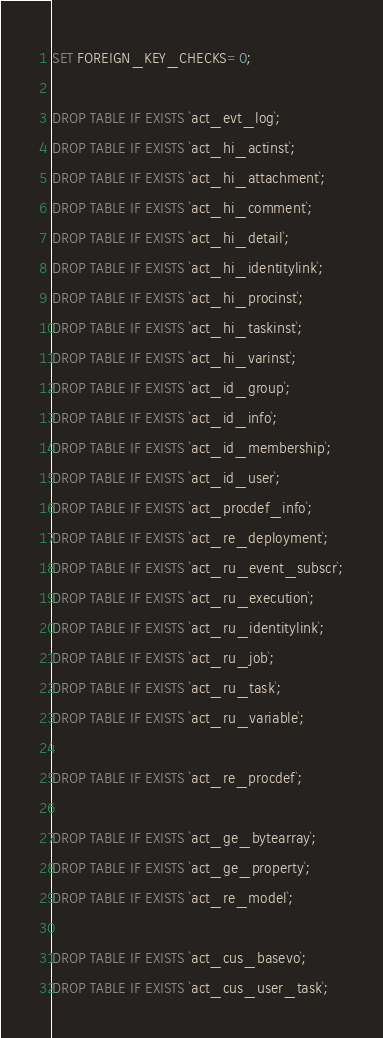<code> <loc_0><loc_0><loc_500><loc_500><_SQL_>
SET FOREIGN_KEY_CHECKS=0;

DROP TABLE IF EXISTS `act_evt_log`;
DROP TABLE IF EXISTS `act_hi_actinst`;
DROP TABLE IF EXISTS `act_hi_attachment`;
DROP TABLE IF EXISTS `act_hi_comment`;
DROP TABLE IF EXISTS `act_hi_detail`;
DROP TABLE IF EXISTS `act_hi_identitylink`;
DROP TABLE IF EXISTS `act_hi_procinst`;
DROP TABLE IF EXISTS `act_hi_taskinst`;
DROP TABLE IF EXISTS `act_hi_varinst`;
DROP TABLE IF EXISTS `act_id_group`;
DROP TABLE IF EXISTS `act_id_info`;
DROP TABLE IF EXISTS `act_id_membership`;
DROP TABLE IF EXISTS `act_id_user`;
DROP TABLE IF EXISTS `act_procdef_info`;
DROP TABLE IF EXISTS `act_re_deployment`;
DROP TABLE IF EXISTS `act_ru_event_subscr`;
DROP TABLE IF EXISTS `act_ru_execution`;
DROP TABLE IF EXISTS `act_ru_identitylink`;
DROP TABLE IF EXISTS `act_ru_job`;
DROP TABLE IF EXISTS `act_ru_task`;
DROP TABLE IF EXISTS `act_ru_variable`;

DROP TABLE IF EXISTS `act_re_procdef`;

DROP TABLE IF EXISTS `act_ge_bytearray`;
DROP TABLE IF EXISTS `act_ge_property`;
DROP TABLE IF EXISTS `act_re_model`;

DROP TABLE IF EXISTS `act_cus_basevo`;
DROP TABLE IF EXISTS `act_cus_user_task`;
</code> 